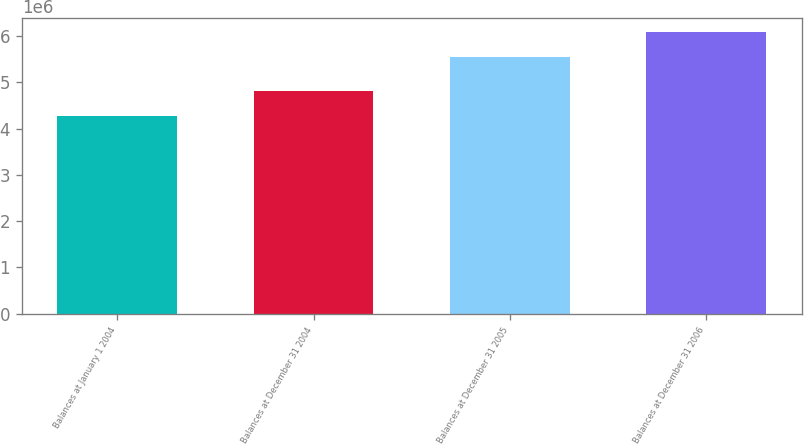<chart> <loc_0><loc_0><loc_500><loc_500><bar_chart><fcel>Balances at January 1 2004<fcel>Balances at December 31 2004<fcel>Balances at December 31 2005<fcel>Balances at December 31 2006<nl><fcel>4.2629e+06<fcel>4.80452e+06<fcel>5.55446e+06<fcel>6.09158e+06<nl></chart> 